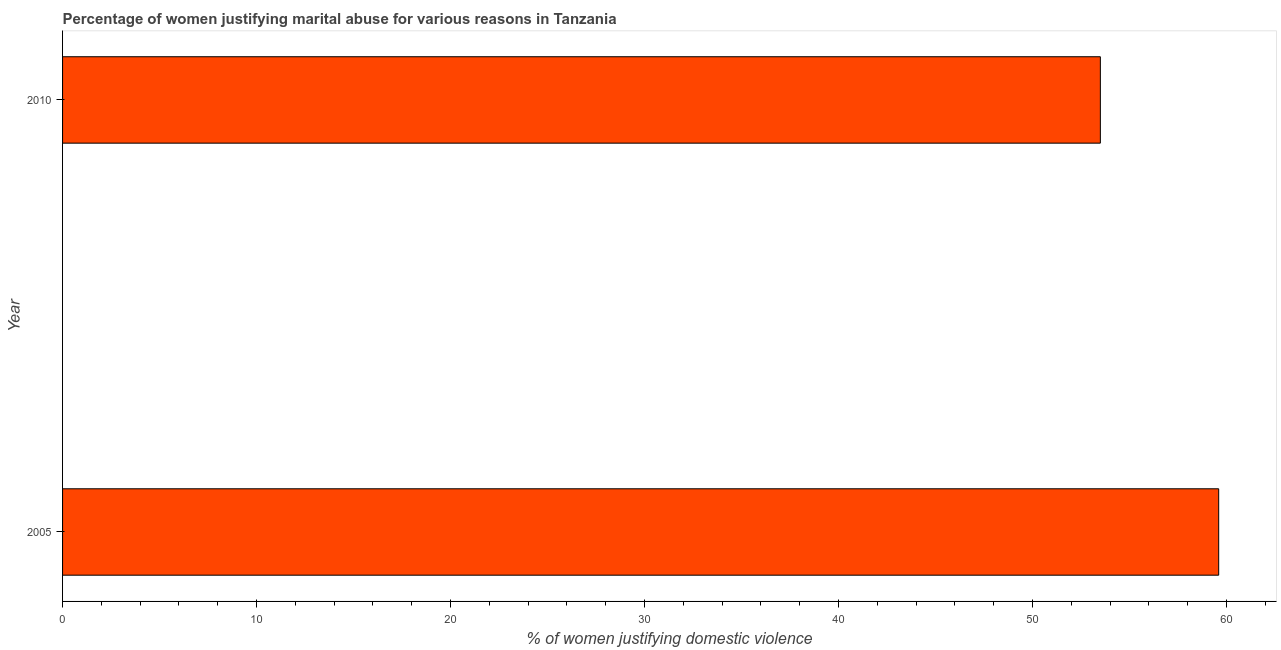Does the graph contain grids?
Offer a terse response. No. What is the title of the graph?
Make the answer very short. Percentage of women justifying marital abuse for various reasons in Tanzania. What is the label or title of the X-axis?
Keep it short and to the point. % of women justifying domestic violence. What is the label or title of the Y-axis?
Give a very brief answer. Year. What is the percentage of women justifying marital abuse in 2005?
Offer a terse response. 59.6. Across all years, what is the maximum percentage of women justifying marital abuse?
Your answer should be compact. 59.6. Across all years, what is the minimum percentage of women justifying marital abuse?
Provide a succinct answer. 53.5. What is the sum of the percentage of women justifying marital abuse?
Your answer should be compact. 113.1. What is the average percentage of women justifying marital abuse per year?
Offer a terse response. 56.55. What is the median percentage of women justifying marital abuse?
Your answer should be compact. 56.55. In how many years, is the percentage of women justifying marital abuse greater than 30 %?
Give a very brief answer. 2. What is the ratio of the percentage of women justifying marital abuse in 2005 to that in 2010?
Your response must be concise. 1.11. Are all the bars in the graph horizontal?
Offer a terse response. Yes. Are the values on the major ticks of X-axis written in scientific E-notation?
Offer a very short reply. No. What is the % of women justifying domestic violence in 2005?
Make the answer very short. 59.6. What is the % of women justifying domestic violence of 2010?
Your answer should be compact. 53.5. What is the difference between the % of women justifying domestic violence in 2005 and 2010?
Provide a succinct answer. 6.1. What is the ratio of the % of women justifying domestic violence in 2005 to that in 2010?
Offer a very short reply. 1.11. 